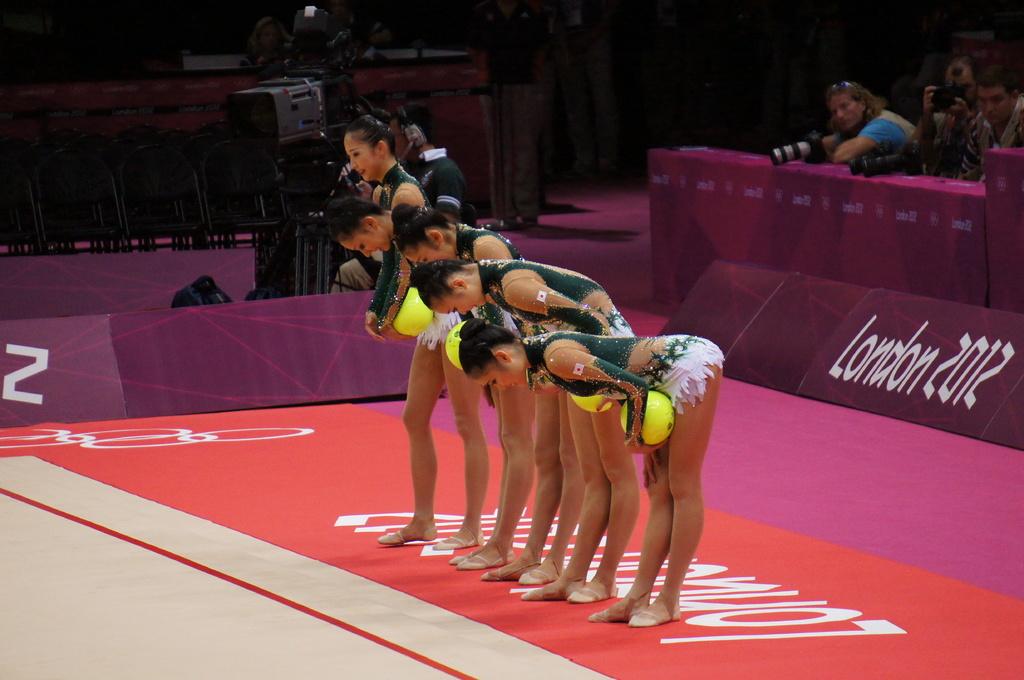What city hosted this competition?
Ensure brevity in your answer.  London. 